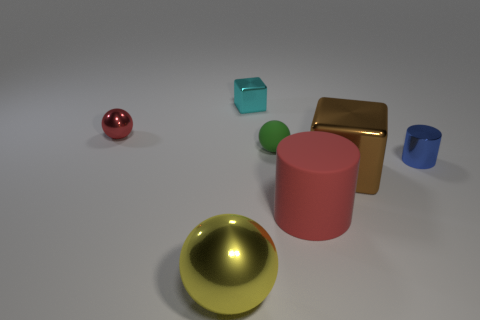Add 1 large red balls. How many objects exist? 8 Subtract all cylinders. How many objects are left? 5 Subtract all metallic cylinders. Subtract all big yellow cylinders. How many objects are left? 6 Add 2 big rubber cylinders. How many big rubber cylinders are left? 3 Add 4 tiny cyan objects. How many tiny cyan objects exist? 5 Subtract 1 cyan cubes. How many objects are left? 6 